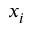<formula> <loc_0><loc_0><loc_500><loc_500>x _ { i }</formula> 